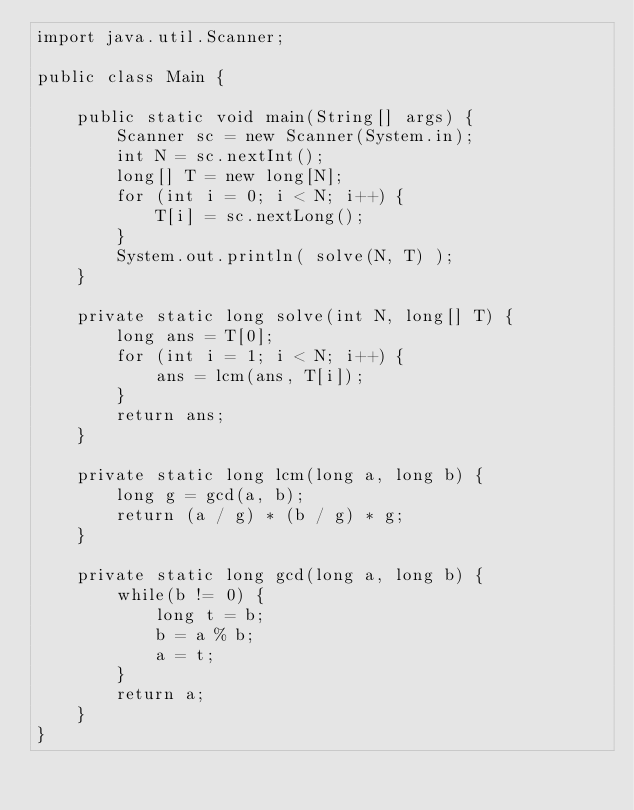<code> <loc_0><loc_0><loc_500><loc_500><_Java_>import java.util.Scanner;

public class Main {

    public static void main(String[] args) {
        Scanner sc = new Scanner(System.in);
        int N = sc.nextInt();
        long[] T = new long[N];
        for (int i = 0; i < N; i++) {
            T[i] = sc.nextLong();
        }
        System.out.println( solve(N, T) );
    }

    private static long solve(int N, long[] T) {
        long ans = T[0];
        for (int i = 1; i < N; i++) {
            ans = lcm(ans, T[i]);
        }
        return ans;
    }

    private static long lcm(long a, long b) {
        long g = gcd(a, b);
        return (a / g) * (b / g) * g;
    }

    private static long gcd(long a, long b) {
        while(b != 0) {
            long t = b;
            b = a % b;
            a = t;
        }
        return a;
    }
}</code> 